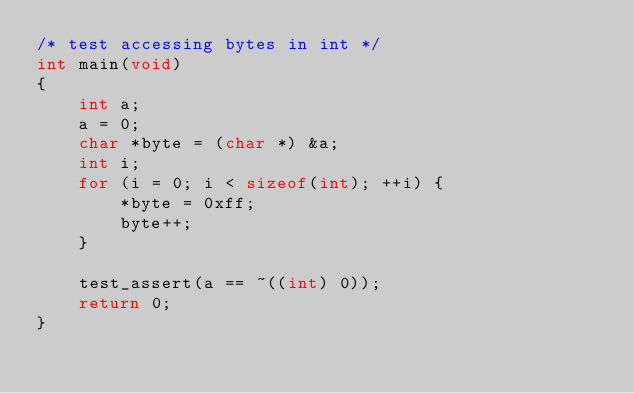Convert code to text. <code><loc_0><loc_0><loc_500><loc_500><_C_>/* test accessing bytes in int */
int main(void)
{
	int a;
	a = 0;
	char *byte = (char *) &a;
	int i;
	for (i = 0; i < sizeof(int); ++i) {
		*byte = 0xff;
		byte++;
	}

	test_assert(a == ~((int) 0));
	return 0;
}
</code> 